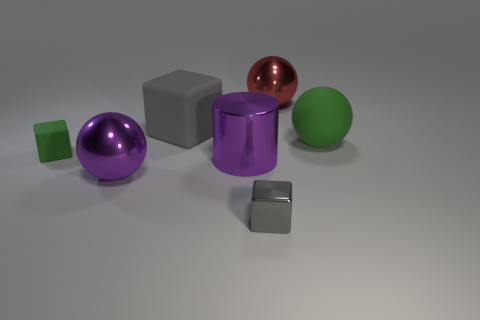How many other things are made of the same material as the big gray thing?
Your answer should be compact. 2. What color is the matte block behind the small block behind the metal sphere that is to the left of the large red shiny ball?
Your answer should be very brief. Gray. What is the shape of the green object on the right side of the thing behind the gray rubber cube?
Offer a very short reply. Sphere. Is the number of purple shiny objects on the left side of the large purple cylinder greater than the number of gray metal objects?
Your response must be concise. No. There is a tiny thing in front of the green block; does it have the same shape as the large green rubber thing?
Your answer should be very brief. No. Are there any purple shiny objects that have the same shape as the small green object?
Give a very brief answer. No. How many objects are objects that are left of the green ball or large purple cylinders?
Provide a short and direct response. 6. Are there more big metal cylinders than yellow cylinders?
Your answer should be very brief. Yes. Is there a green rubber block that has the same size as the gray rubber object?
Give a very brief answer. No. How many objects are large metallic things that are to the left of the big cylinder or green matte things to the left of the big red sphere?
Give a very brief answer. 2. 